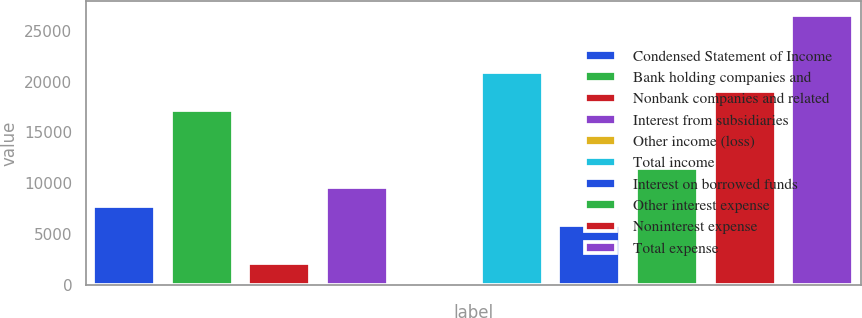Convert chart. <chart><loc_0><loc_0><loc_500><loc_500><bar_chart><fcel>Condensed Statement of Income<fcel>Bank holding companies and<fcel>Nonbank companies and related<fcel>Interest from subsidiaries<fcel>Other income (loss)<fcel>Total income<fcel>Interest on borrowed funds<fcel>Other interest expense<fcel>Noninterest expense<fcel>Total expense<nl><fcel>7758.6<fcel>17165.6<fcel>2114.4<fcel>9640<fcel>233<fcel>20928.4<fcel>5877.2<fcel>11521.4<fcel>19047<fcel>26572.6<nl></chart> 